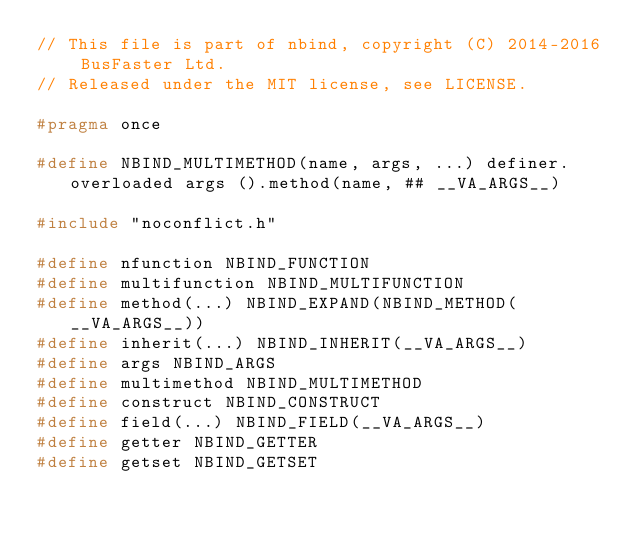<code> <loc_0><loc_0><loc_500><loc_500><_C_>// This file is part of nbind, copyright (C) 2014-2016 BusFaster Ltd.
// Released under the MIT license, see LICENSE.

#pragma once

#define NBIND_MULTIMETHOD(name, args, ...) definer.overloaded args ().method(name, ## __VA_ARGS__)

#include "noconflict.h"

#define nfunction NBIND_FUNCTION
#define multifunction NBIND_MULTIFUNCTION
#define method(...) NBIND_EXPAND(NBIND_METHOD(__VA_ARGS__))
#define inherit(...) NBIND_INHERIT(__VA_ARGS__)
#define args NBIND_ARGS
#define multimethod NBIND_MULTIMETHOD
#define construct NBIND_CONSTRUCT
#define field(...) NBIND_FIELD(__VA_ARGS__)
#define getter NBIND_GETTER
#define getset NBIND_GETSET
</code> 